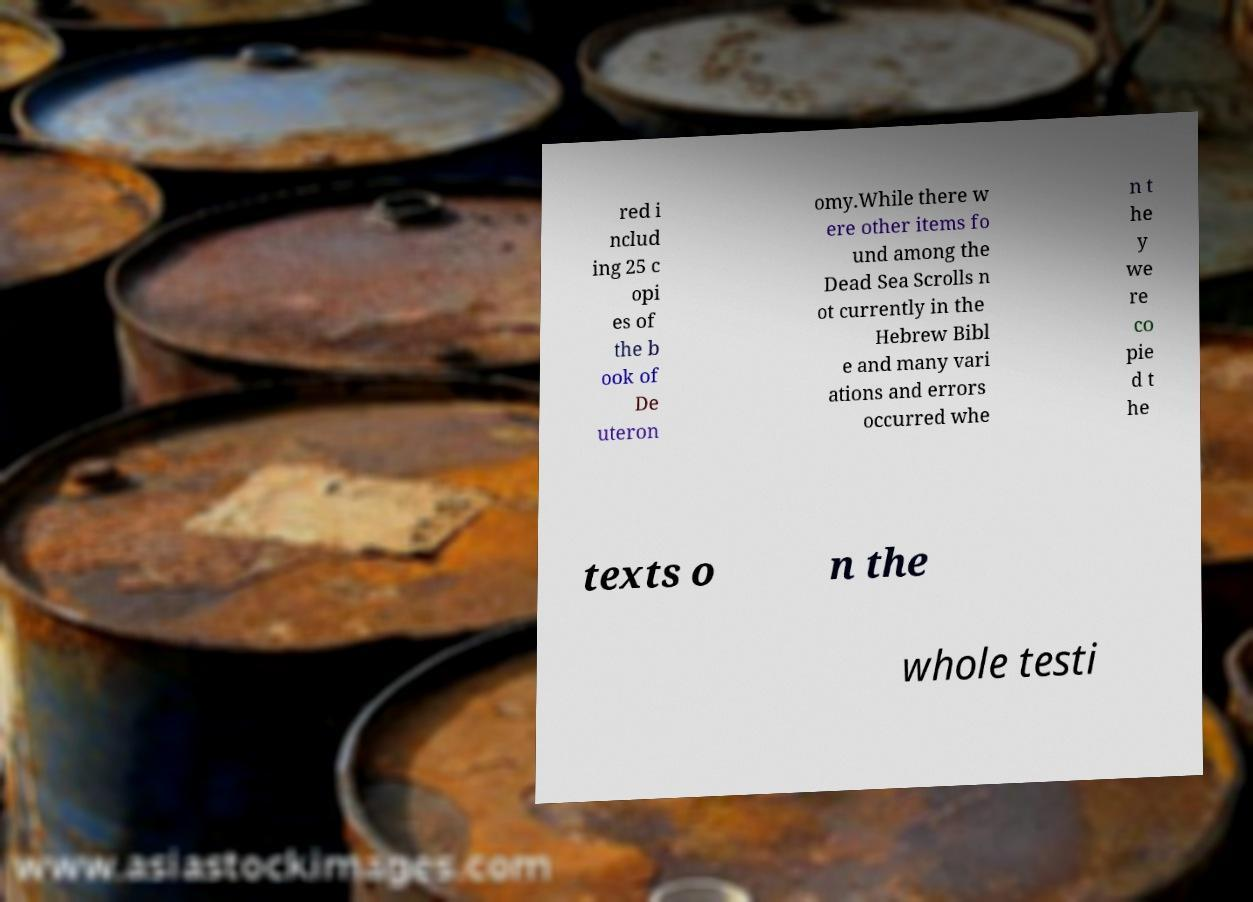What messages or text are displayed in this image? I need them in a readable, typed format. red i nclud ing 25 c opi es of the b ook of De uteron omy.While there w ere other items fo und among the Dead Sea Scrolls n ot currently in the Hebrew Bibl e and many vari ations and errors occurred whe n t he y we re co pie d t he texts o n the whole testi 